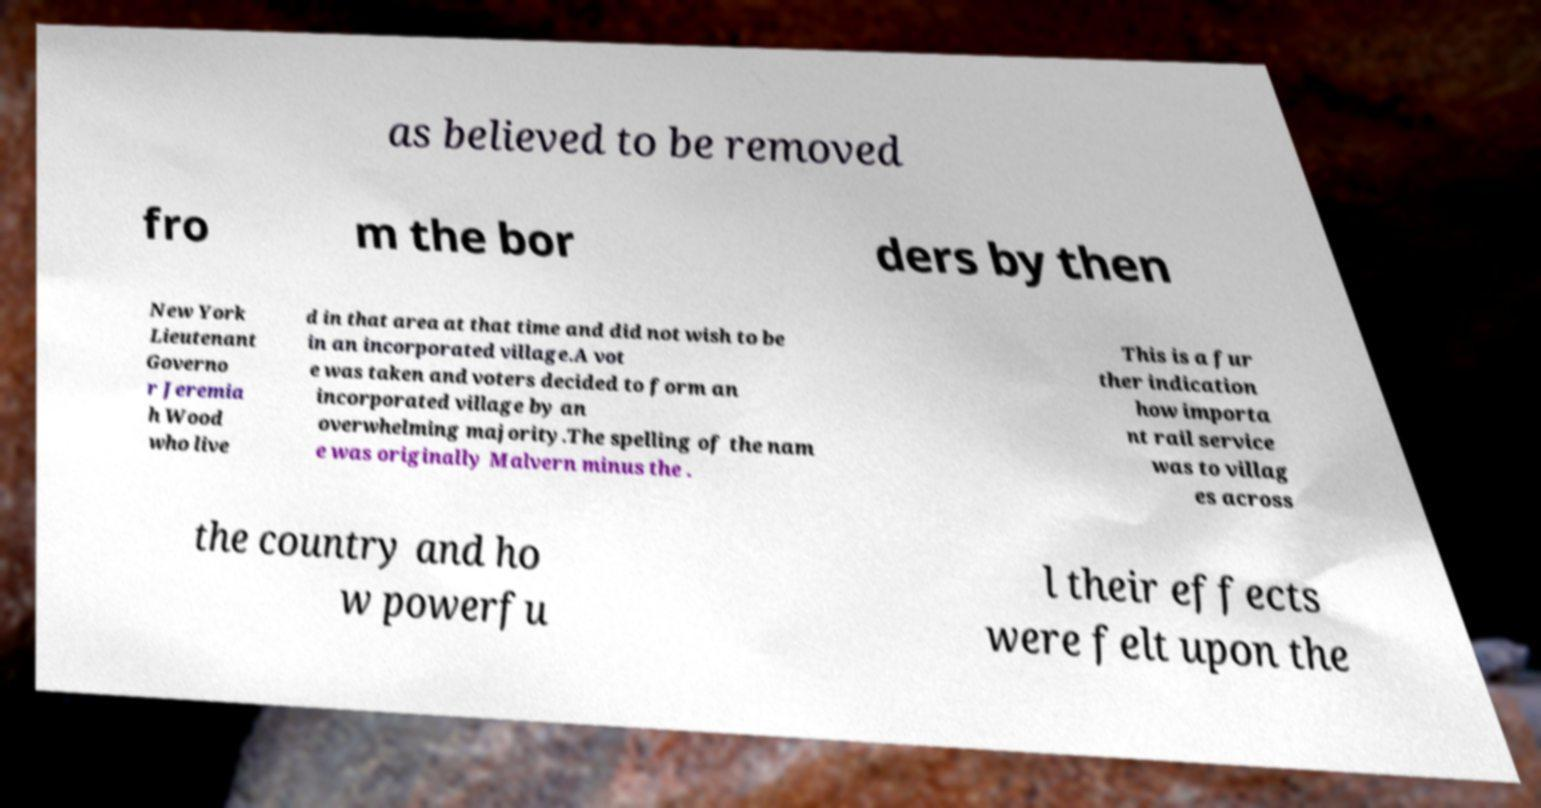I need the written content from this picture converted into text. Can you do that? as believed to be removed fro m the bor ders by then New York Lieutenant Governo r Jeremia h Wood who live d in that area at that time and did not wish to be in an incorporated village.A vot e was taken and voters decided to form an incorporated village by an overwhelming majority.The spelling of the nam e was originally Malvern minus the . This is a fur ther indication how importa nt rail service was to villag es across the country and ho w powerfu l their effects were felt upon the 